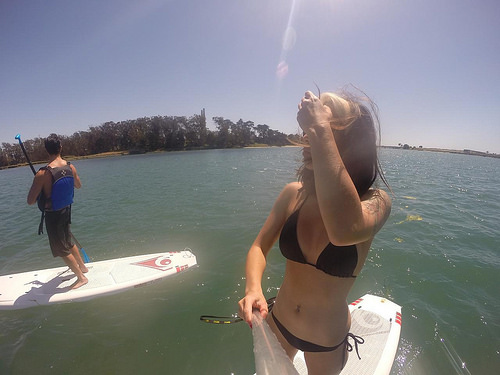<image>
Is there a board in the water? Yes. The board is contained within or inside the water, showing a containment relationship. 